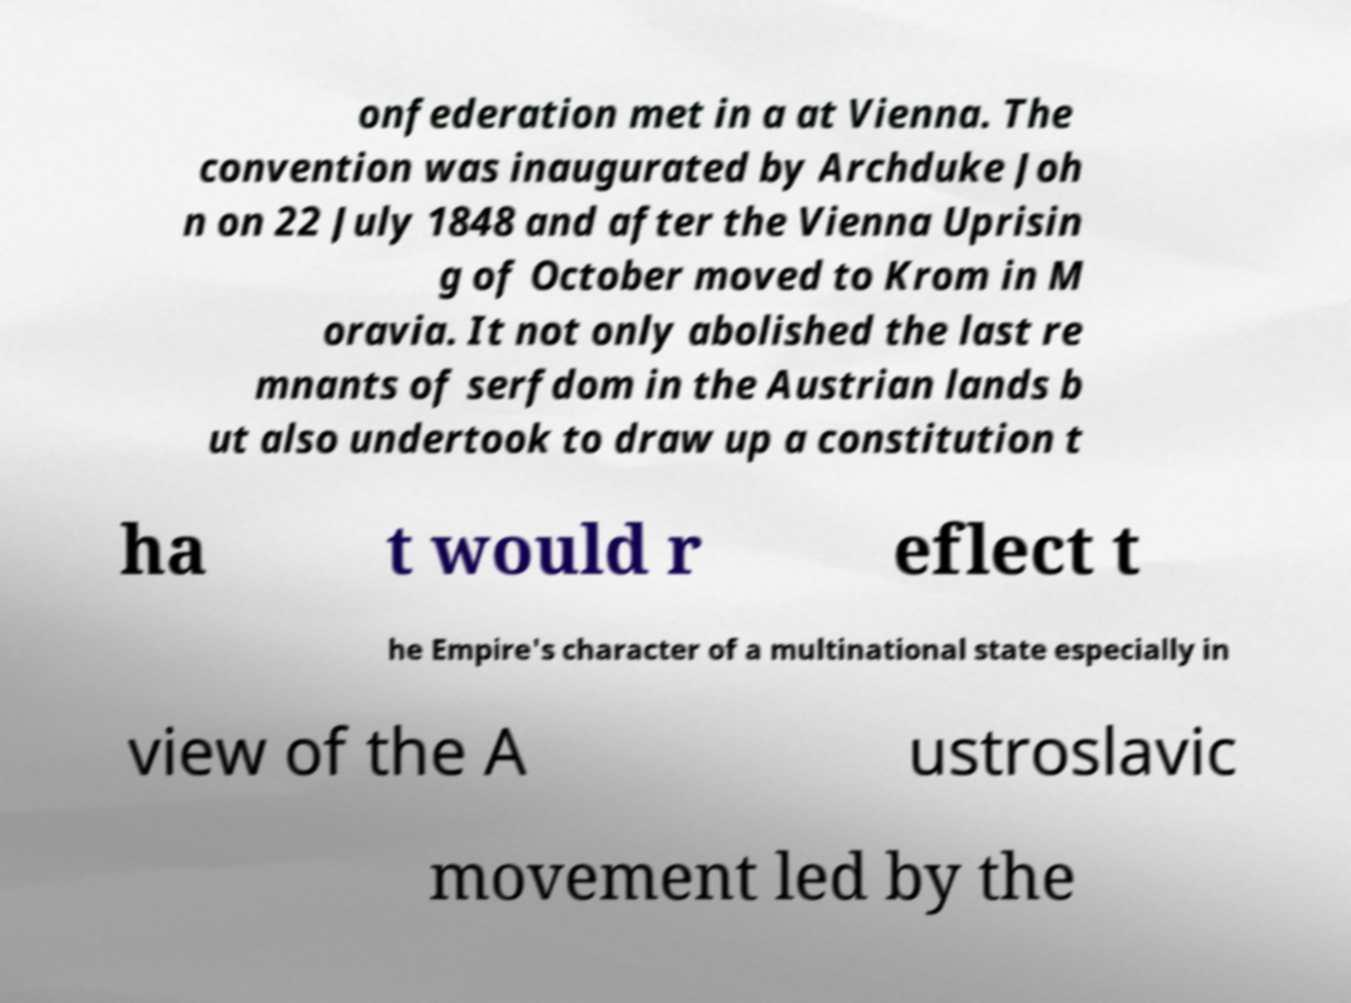I need the written content from this picture converted into text. Can you do that? onfederation met in a at Vienna. The convention was inaugurated by Archduke Joh n on 22 July 1848 and after the Vienna Uprisin g of October moved to Krom in M oravia. It not only abolished the last re mnants of serfdom in the Austrian lands b ut also undertook to draw up a constitution t ha t would r eflect t he Empire's character of a multinational state especially in view of the A ustroslavic movement led by the 